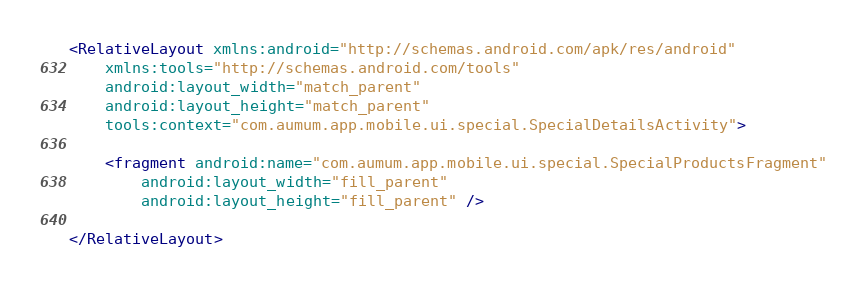Convert code to text. <code><loc_0><loc_0><loc_500><loc_500><_XML_><RelativeLayout xmlns:android="http://schemas.android.com/apk/res/android"
    xmlns:tools="http://schemas.android.com/tools"
    android:layout_width="match_parent"
    android:layout_height="match_parent"
    tools:context="com.aumum.app.mobile.ui.special.SpecialDetailsActivity">

    <fragment android:name="com.aumum.app.mobile.ui.special.SpecialProductsFragment"
        android:layout_width="fill_parent"
        android:layout_height="fill_parent" />

</RelativeLayout></code> 